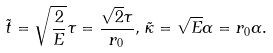Convert formula to latex. <formula><loc_0><loc_0><loc_500><loc_500>\tilde { t } = \sqrt { \frac { 2 } { E } } \tau = \frac { \sqrt { 2 } \tau } { r _ { 0 } } , \, \tilde { \kappa } = \sqrt { E } \alpha = r _ { 0 } \alpha .</formula> 